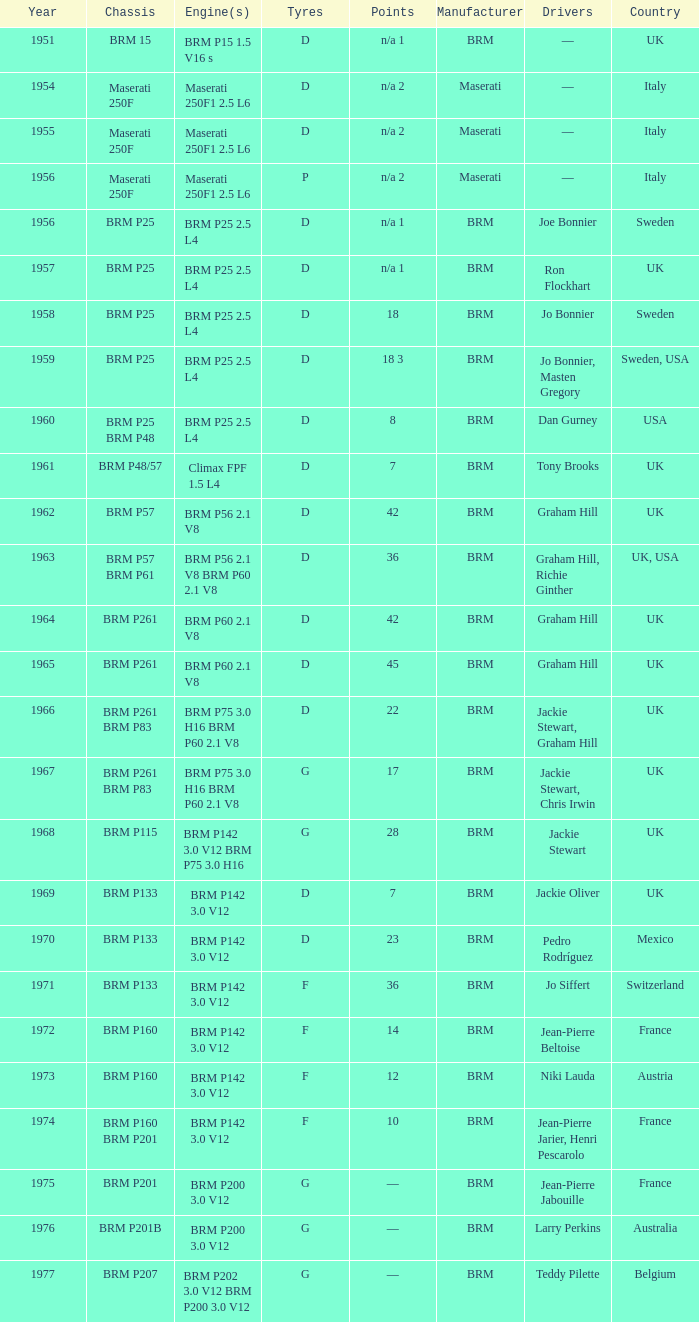Name the chassis of 1961 BRM P48/57. 